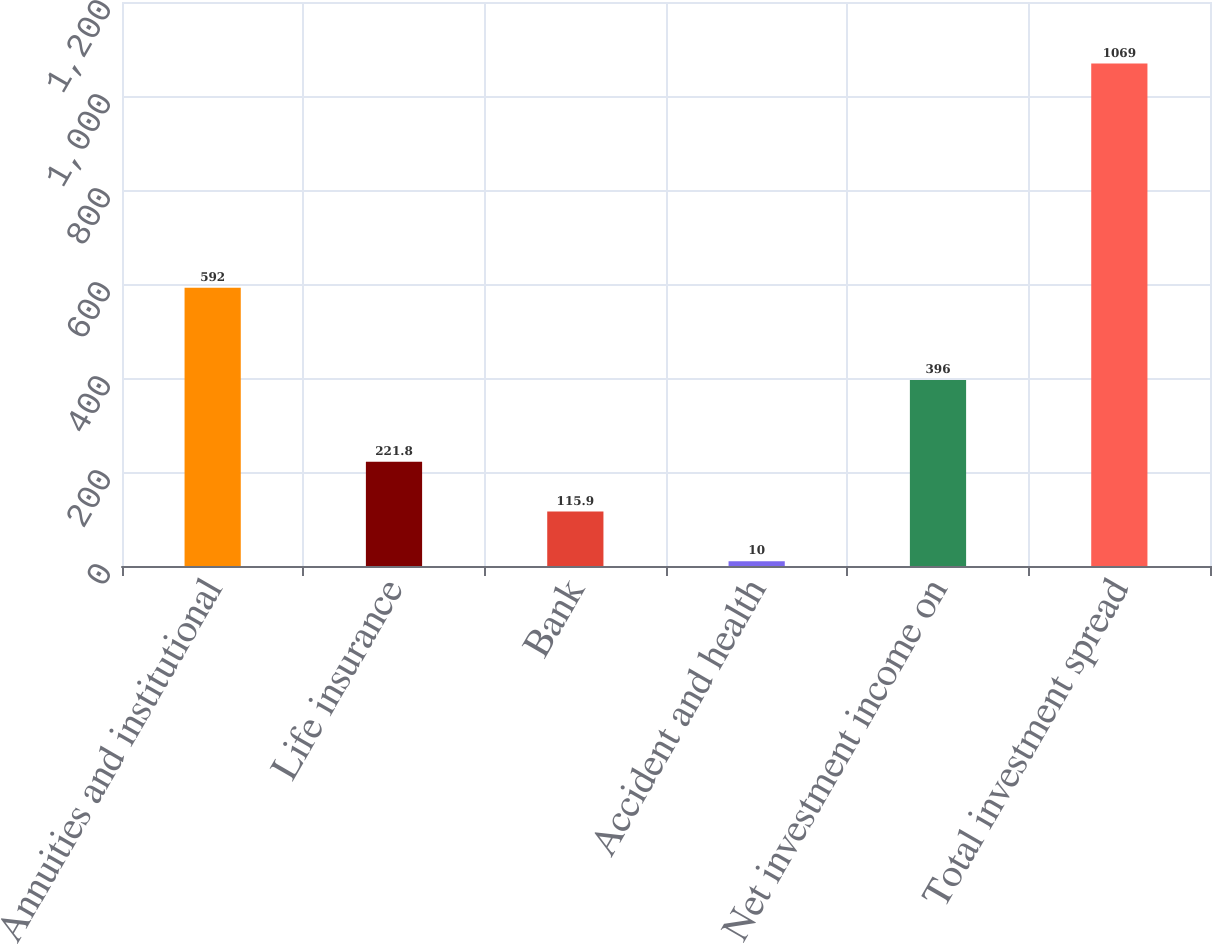<chart> <loc_0><loc_0><loc_500><loc_500><bar_chart><fcel>Annuities and institutional<fcel>Life insurance<fcel>Bank<fcel>Accident and health<fcel>Net investment income on<fcel>Total investment spread<nl><fcel>592<fcel>221.8<fcel>115.9<fcel>10<fcel>396<fcel>1069<nl></chart> 